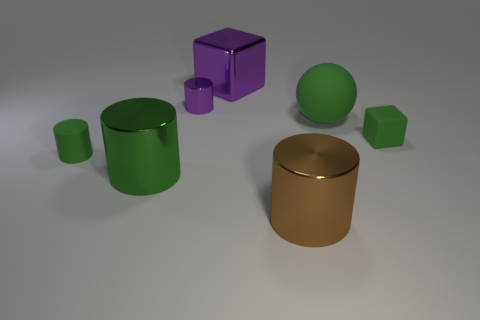Add 2 blue metallic objects. How many objects exist? 9 Subtract all cylinders. How many objects are left? 3 Subtract 0 brown spheres. How many objects are left? 7 Subtract all large things. Subtract all big cylinders. How many objects are left? 1 Add 5 purple cubes. How many purple cubes are left? 6 Add 5 balls. How many balls exist? 6 